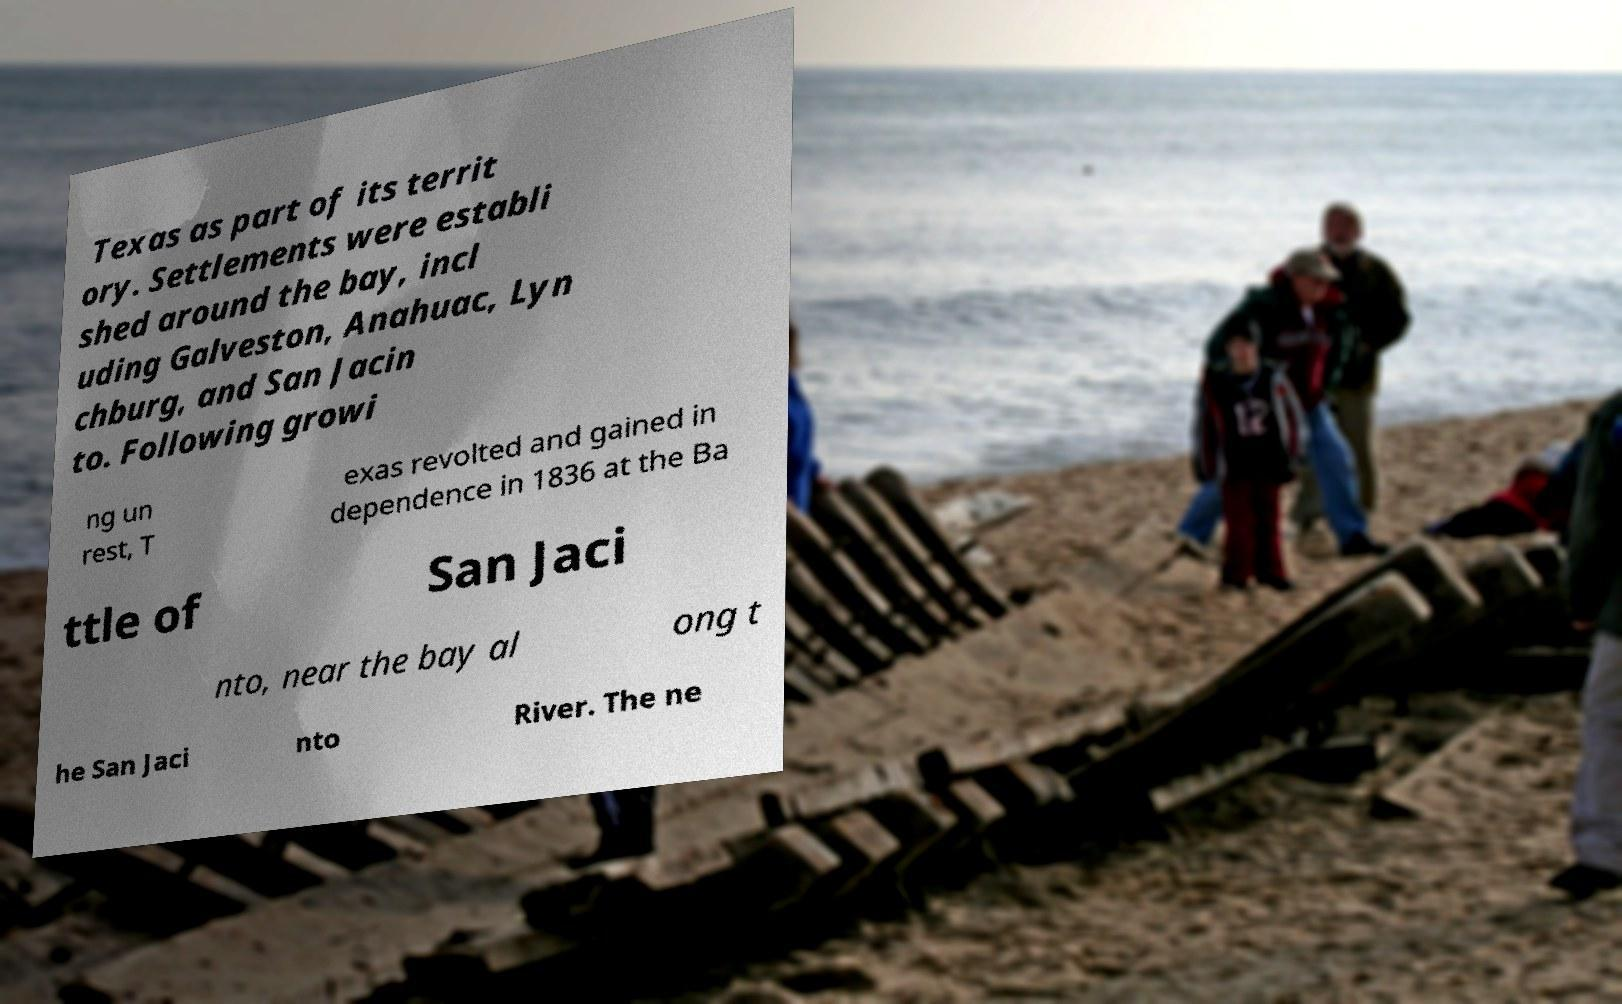Please identify and transcribe the text found in this image. Texas as part of its territ ory. Settlements were establi shed around the bay, incl uding Galveston, Anahuac, Lyn chburg, and San Jacin to. Following growi ng un rest, T exas revolted and gained in dependence in 1836 at the Ba ttle of San Jaci nto, near the bay al ong t he San Jaci nto River. The ne 